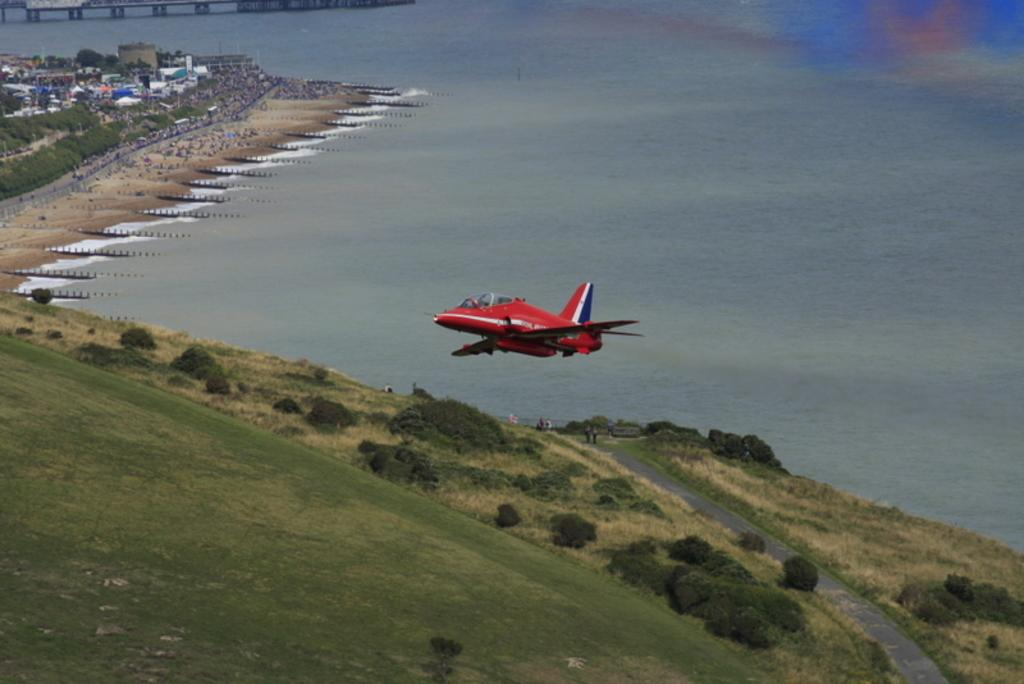What is the main subject of the image? The main subject of the image is an airplane flying in the sky. What can be seen in the background of the image? There is a group of trees, a building, water, and a bridge visible in the background. What type of natural feature is present in the background? There is a group of trees in the background. What type of man-made structure can be seen in the background? There is a building and a bridge visible in the background. Where are the chickens meeting in the image? There are no chickens or meetings present in the image. 